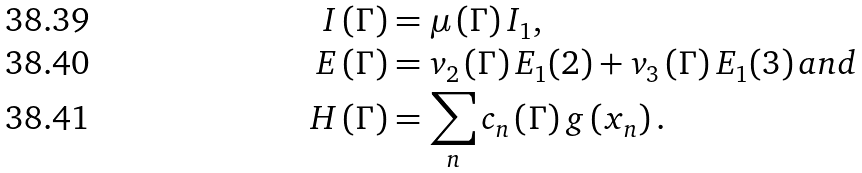<formula> <loc_0><loc_0><loc_500><loc_500>I \left ( \Gamma \right ) & = \mu \left ( \Gamma \right ) I _ { 1 } , \\ E \left ( \Gamma \right ) & = v _ { 2 } \left ( \Gamma \right ) E _ { 1 } ( 2 ) + v _ { 3 } \left ( \Gamma \right ) E _ { 1 } ( 3 ) \, a n d \\ H \left ( \Gamma \right ) & = \sum _ { n } c _ { n } \left ( \Gamma \right ) g \left ( x _ { n } \right ) .</formula> 